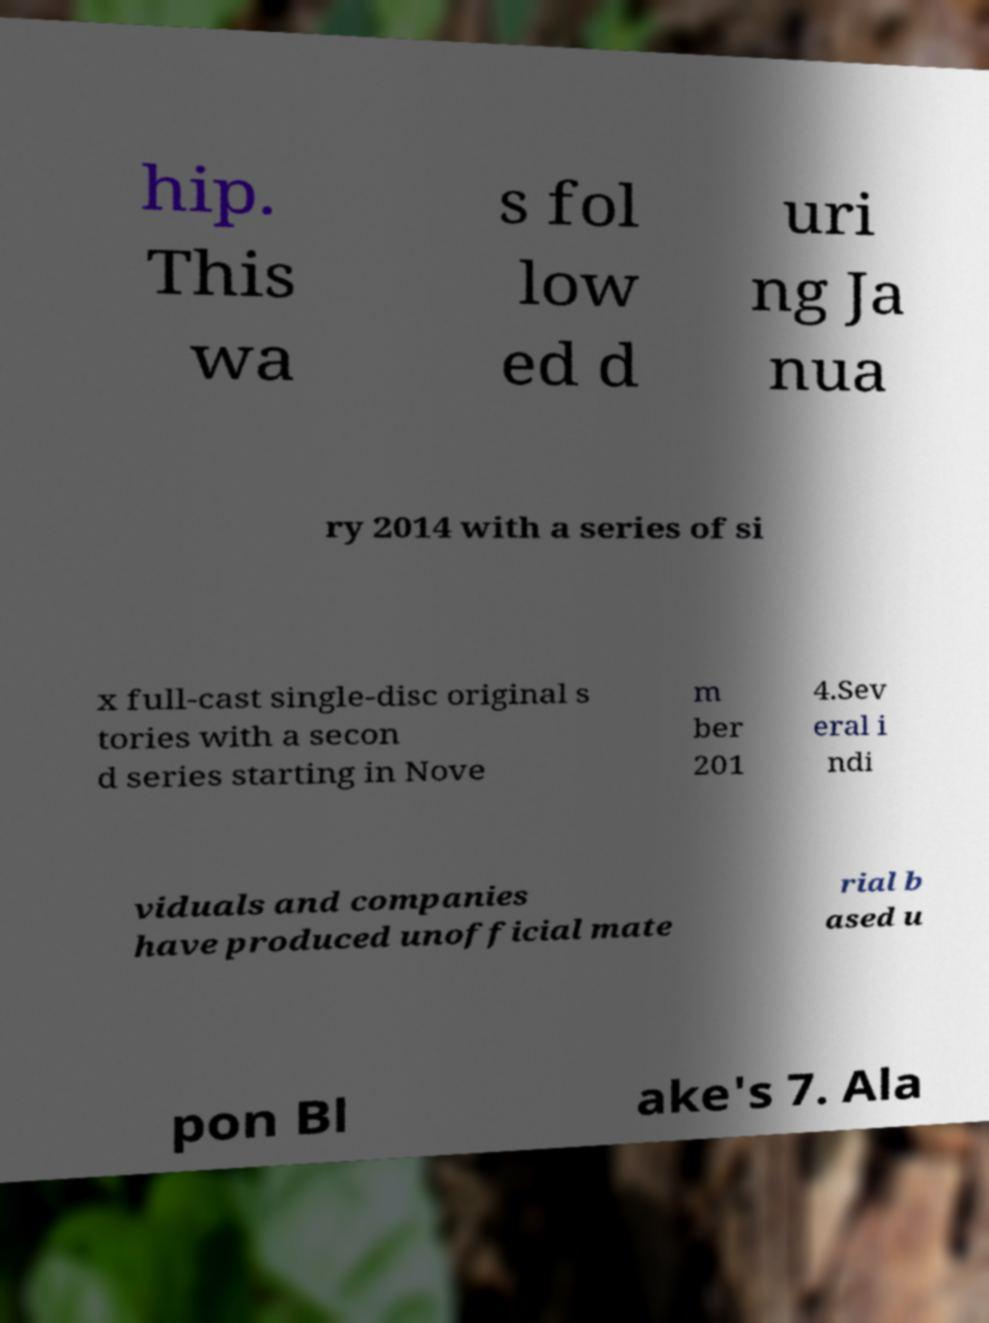Please identify and transcribe the text found in this image. hip. This wa s fol low ed d uri ng Ja nua ry 2014 with a series of si x full-cast single-disc original s tories with a secon d series starting in Nove m ber 201 4.Sev eral i ndi viduals and companies have produced unofficial mate rial b ased u pon Bl ake's 7. Ala 